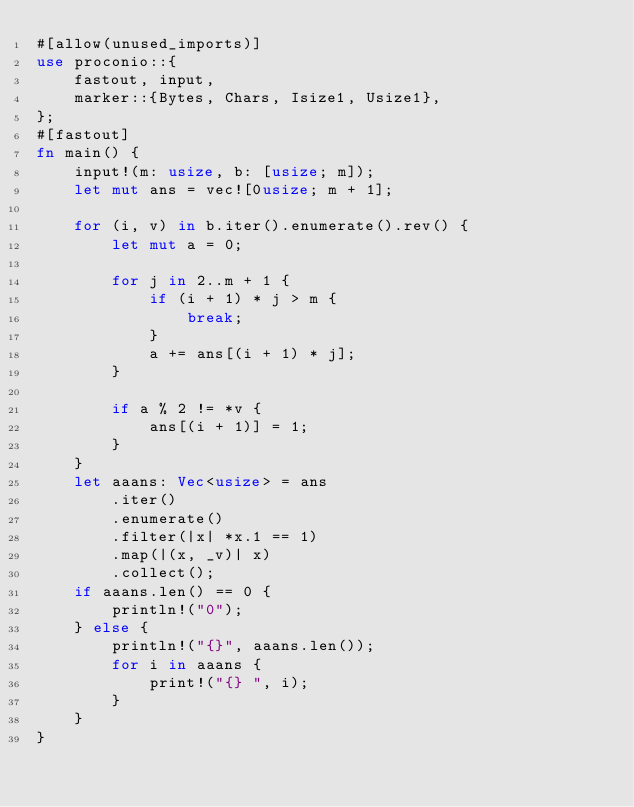Convert code to text. <code><loc_0><loc_0><loc_500><loc_500><_Rust_>#[allow(unused_imports)]
use proconio::{
    fastout, input,
    marker::{Bytes, Chars, Isize1, Usize1},
};
#[fastout]
fn main() {
    input!(m: usize, b: [usize; m]);
    let mut ans = vec![0usize; m + 1];

    for (i, v) in b.iter().enumerate().rev() {
        let mut a = 0;

        for j in 2..m + 1 {
            if (i + 1) * j > m {
                break;
            }
            a += ans[(i + 1) * j];
        }

        if a % 2 != *v {
            ans[(i + 1)] = 1;
        }
    }
    let aaans: Vec<usize> = ans
        .iter()
        .enumerate()
        .filter(|x| *x.1 == 1)
        .map(|(x, _v)| x)
        .collect();
    if aaans.len() == 0 {
        println!("0");
    } else {
        println!("{}", aaans.len());
        for i in aaans {
            print!("{} ", i);
        }
    }
}
</code> 